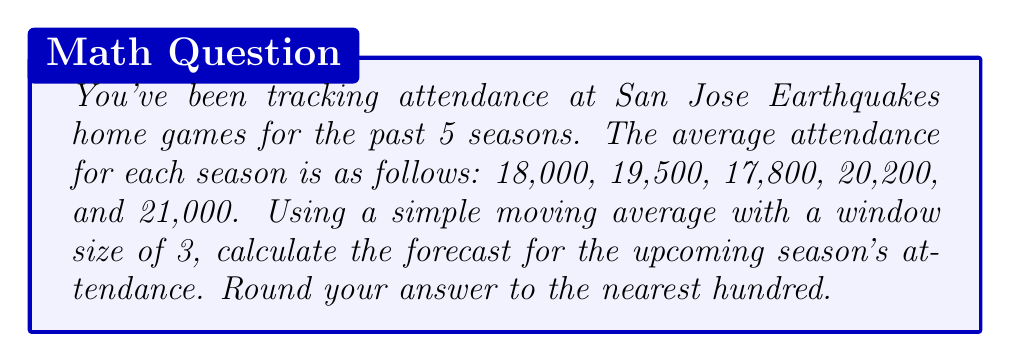Solve this math problem. To solve this problem, we'll use a simple moving average (SMA) with a window size of 3 to forecast the upcoming season's attendance. Here's the step-by-step process:

1. Identify the data points:
   Season 1: 18,000
   Season 2: 19,500
   Season 3: 17,800
   Season 4: 20,200
   Season 5: 21,000

2. Calculate the SMA with a window size of 3 for the last three seasons:

   $$SMA = \frac{1}{3}(A_{t-2} + A_{t-1} + A_t)$$

   Where $A_t$ represents the attendance in season $t$.

3. Plug in the values:

   $$SMA = \frac{1}{3}(17,800 + 20,200 + 21,000)$$

4. Perform the calculation:

   $$SMA = \frac{1}{3}(59,000) = 19,666.67$$

5. Round the result to the nearest hundred:

   19,666.67 rounds to 19,700

This simple moving average forecast assumes that the trend observed in the last three seasons will continue into the next season.
Answer: 19,700 